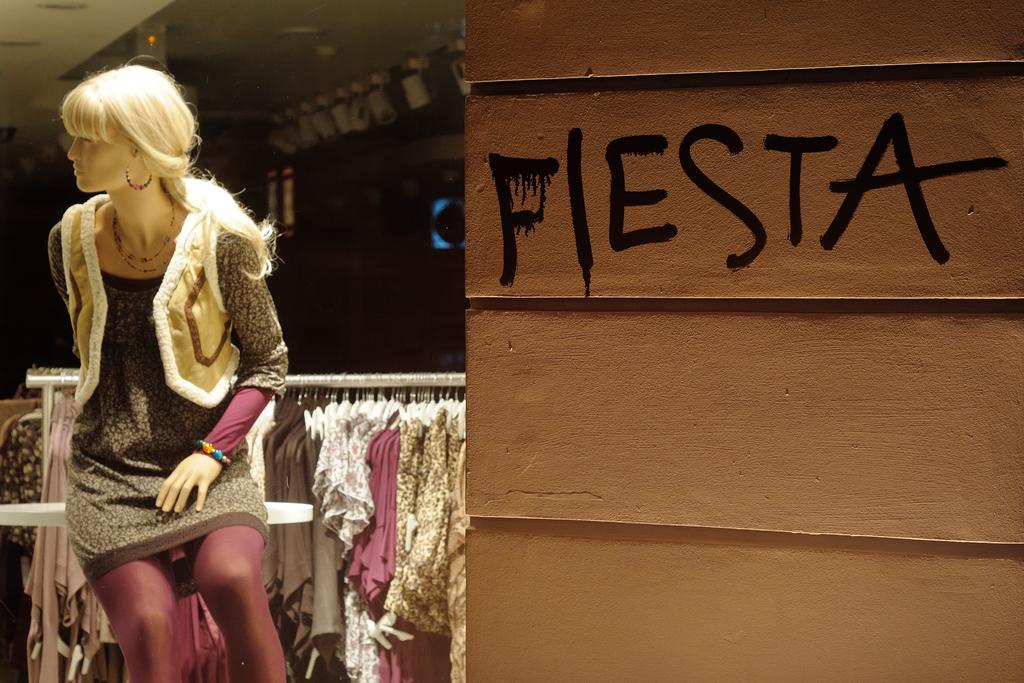What is on the left side of the image? There is a mannequin wearing a dress on the left side of the image. What can be seen on the right side of the image? There is a wall on the right side of the image. What is visible in the background of the image? There are lights and dresses in the background of the image. What type of square is present in the image? There is no square present in the image. Can you tell me the relationship between the mannequin and the father in the image? There is no mention of a father or any familial relationship in the image. 